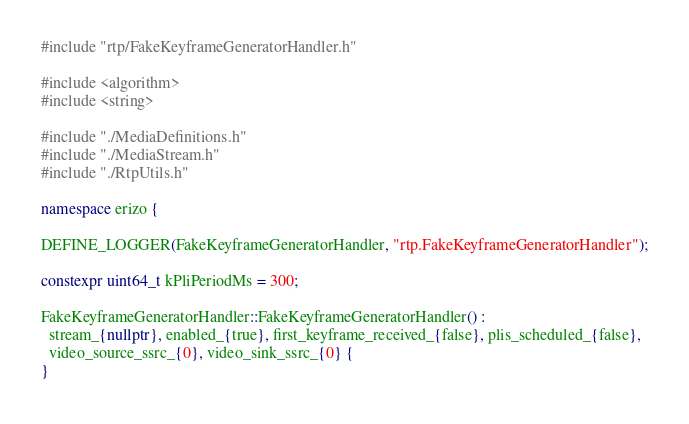<code> <loc_0><loc_0><loc_500><loc_500><_C++_>#include "rtp/FakeKeyframeGeneratorHandler.h"

#include <algorithm>
#include <string>

#include "./MediaDefinitions.h"
#include "./MediaStream.h"
#include "./RtpUtils.h"

namespace erizo {

DEFINE_LOGGER(FakeKeyframeGeneratorHandler, "rtp.FakeKeyframeGeneratorHandler");

constexpr uint64_t kPliPeriodMs = 300;

FakeKeyframeGeneratorHandler::FakeKeyframeGeneratorHandler() :
  stream_{nullptr}, enabled_{true}, first_keyframe_received_{false}, plis_scheduled_{false},
  video_source_ssrc_{0}, video_sink_ssrc_{0} {
}
</code> 